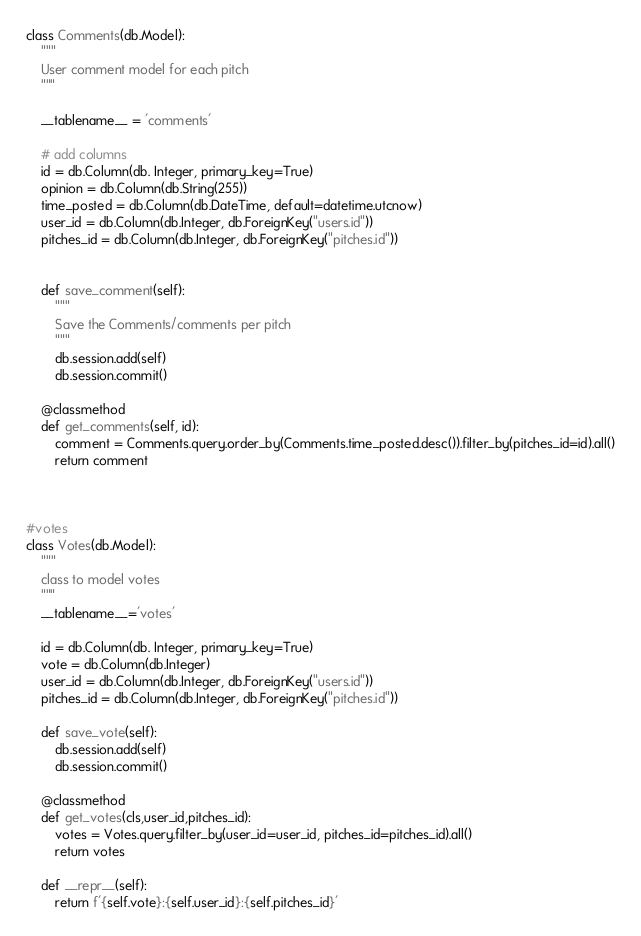<code> <loc_0><loc_0><loc_500><loc_500><_Python_>class Comments(db.Model):
    """
    User comment model for each pitch 
    """

    __tablename__ = 'comments'

    # add columns
    id = db.Column(db. Integer, primary_key=True)
    opinion = db.Column(db.String(255))
    time_posted = db.Column(db.DateTime, default=datetime.utcnow)
    user_id = db.Column(db.Integer, db.ForeignKey("users.id"))
    pitches_id = db.Column(db.Integer, db.ForeignKey("pitches.id"))


    def save_comment(self):
        """
        Save the Comments/comments per pitch
        """
        db.session.add(self)
        db.session.commit()

    @classmethod
    def get_comments(self, id):
        comment = Comments.query.order_by(Comments.time_posted.desc()).filter_by(pitches_id=id).all()
        return comment



#votes
class Votes(db.Model):
    """
    class to model votes
    """
    __tablename__='votes'

    id = db.Column(db. Integer, primary_key=True)
    vote = db.Column(db.Integer)
    user_id = db.Column(db.Integer, db.ForeignKey("users.id"))
    pitches_id = db.Column(db.Integer, db.ForeignKey("pitches.id"))

    def save_vote(self):
        db.session.add(self)
        db.session.commit()

    @classmethod
    def get_votes(cls,user_id,pitches_id):
        votes = Votes.query.filter_by(user_id=user_id, pitches_id=pitches_id).all()
        return votes

    def __repr__(self):
        return f'{self.vote}:{self.user_id}:{self.pitches_id}'</code> 